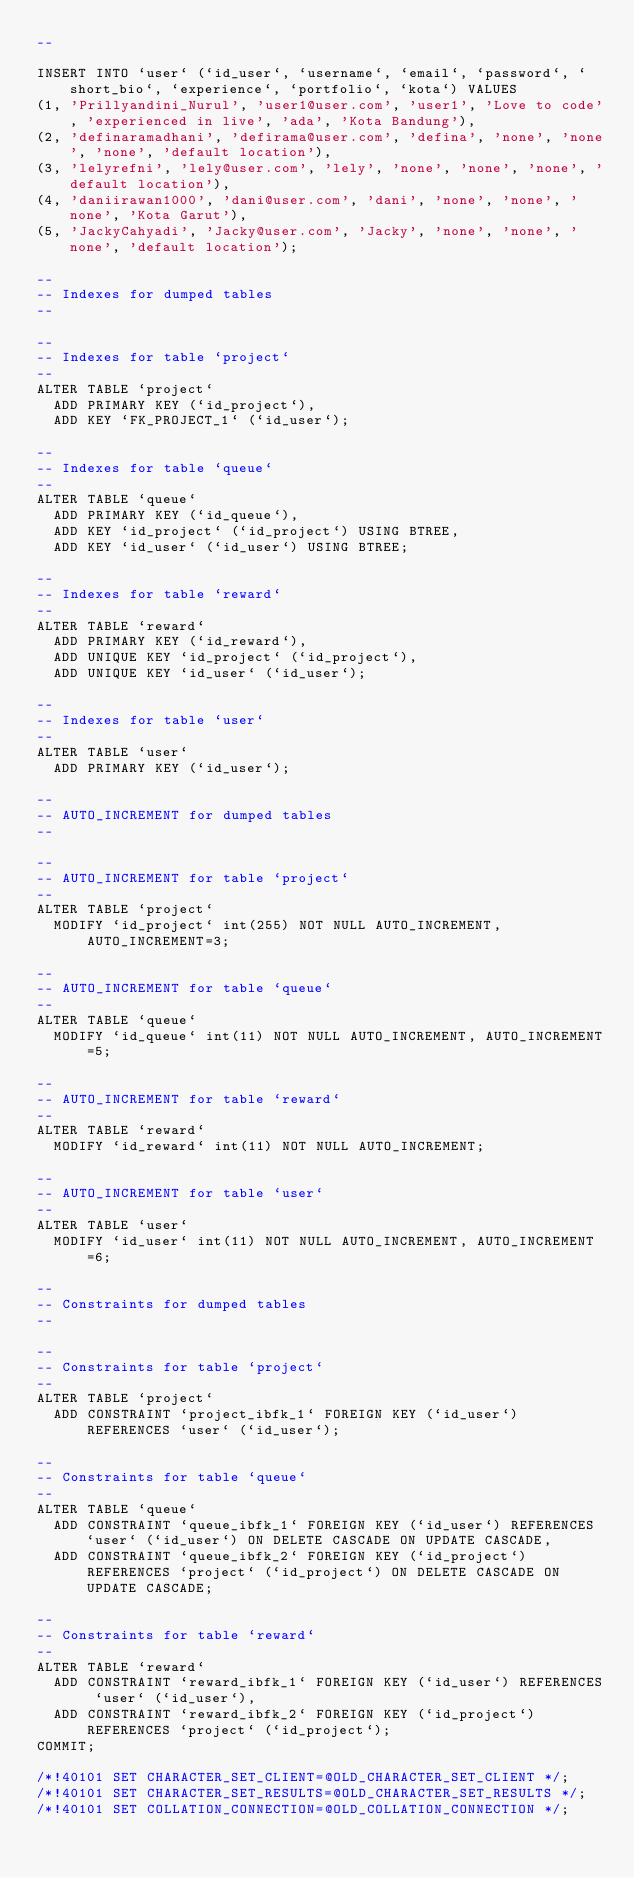<code> <loc_0><loc_0><loc_500><loc_500><_SQL_>--

INSERT INTO `user` (`id_user`, `username`, `email`, `password`, `short_bio`, `experience`, `portfolio`, `kota`) VALUES
(1, 'Prillyandini_Nurul', 'user1@user.com', 'user1', 'Love to code', 'experienced in live', 'ada', 'Kota Bandung'),
(2, 'definaramadhani', 'defirama@user.com', 'defina', 'none', 'none', 'none', 'default location'),
(3, 'lelyrefni', 'lely@user.com', 'lely', 'none', 'none', 'none', 'default location'),
(4, 'daniirawan1000', 'dani@user.com', 'dani', 'none', 'none', 'none', 'Kota Garut'),
(5, 'JackyCahyadi', 'Jacky@user.com', 'Jacky', 'none', 'none', 'none', 'default location');

--
-- Indexes for dumped tables
--

--
-- Indexes for table `project`
--
ALTER TABLE `project`
  ADD PRIMARY KEY (`id_project`),
  ADD KEY `FK_PROJECT_1` (`id_user`);

--
-- Indexes for table `queue`
--
ALTER TABLE `queue`
  ADD PRIMARY KEY (`id_queue`),
  ADD KEY `id_project` (`id_project`) USING BTREE,
  ADD KEY `id_user` (`id_user`) USING BTREE;

--
-- Indexes for table `reward`
--
ALTER TABLE `reward`
  ADD PRIMARY KEY (`id_reward`),
  ADD UNIQUE KEY `id_project` (`id_project`),
  ADD UNIQUE KEY `id_user` (`id_user`);

--
-- Indexes for table `user`
--
ALTER TABLE `user`
  ADD PRIMARY KEY (`id_user`);

--
-- AUTO_INCREMENT for dumped tables
--

--
-- AUTO_INCREMENT for table `project`
--
ALTER TABLE `project`
  MODIFY `id_project` int(255) NOT NULL AUTO_INCREMENT, AUTO_INCREMENT=3;

--
-- AUTO_INCREMENT for table `queue`
--
ALTER TABLE `queue`
  MODIFY `id_queue` int(11) NOT NULL AUTO_INCREMENT, AUTO_INCREMENT=5;

--
-- AUTO_INCREMENT for table `reward`
--
ALTER TABLE `reward`
  MODIFY `id_reward` int(11) NOT NULL AUTO_INCREMENT;

--
-- AUTO_INCREMENT for table `user`
--
ALTER TABLE `user`
  MODIFY `id_user` int(11) NOT NULL AUTO_INCREMENT, AUTO_INCREMENT=6;

--
-- Constraints for dumped tables
--

--
-- Constraints for table `project`
--
ALTER TABLE `project`
  ADD CONSTRAINT `project_ibfk_1` FOREIGN KEY (`id_user`) REFERENCES `user` (`id_user`);

--
-- Constraints for table `queue`
--
ALTER TABLE `queue`
  ADD CONSTRAINT `queue_ibfk_1` FOREIGN KEY (`id_user`) REFERENCES `user` (`id_user`) ON DELETE CASCADE ON UPDATE CASCADE,
  ADD CONSTRAINT `queue_ibfk_2` FOREIGN KEY (`id_project`) REFERENCES `project` (`id_project`) ON DELETE CASCADE ON UPDATE CASCADE;

--
-- Constraints for table `reward`
--
ALTER TABLE `reward`
  ADD CONSTRAINT `reward_ibfk_1` FOREIGN KEY (`id_user`) REFERENCES `user` (`id_user`),
  ADD CONSTRAINT `reward_ibfk_2` FOREIGN KEY (`id_project`) REFERENCES `project` (`id_project`);
COMMIT;

/*!40101 SET CHARACTER_SET_CLIENT=@OLD_CHARACTER_SET_CLIENT */;
/*!40101 SET CHARACTER_SET_RESULTS=@OLD_CHARACTER_SET_RESULTS */;
/*!40101 SET COLLATION_CONNECTION=@OLD_COLLATION_CONNECTION */;
</code> 